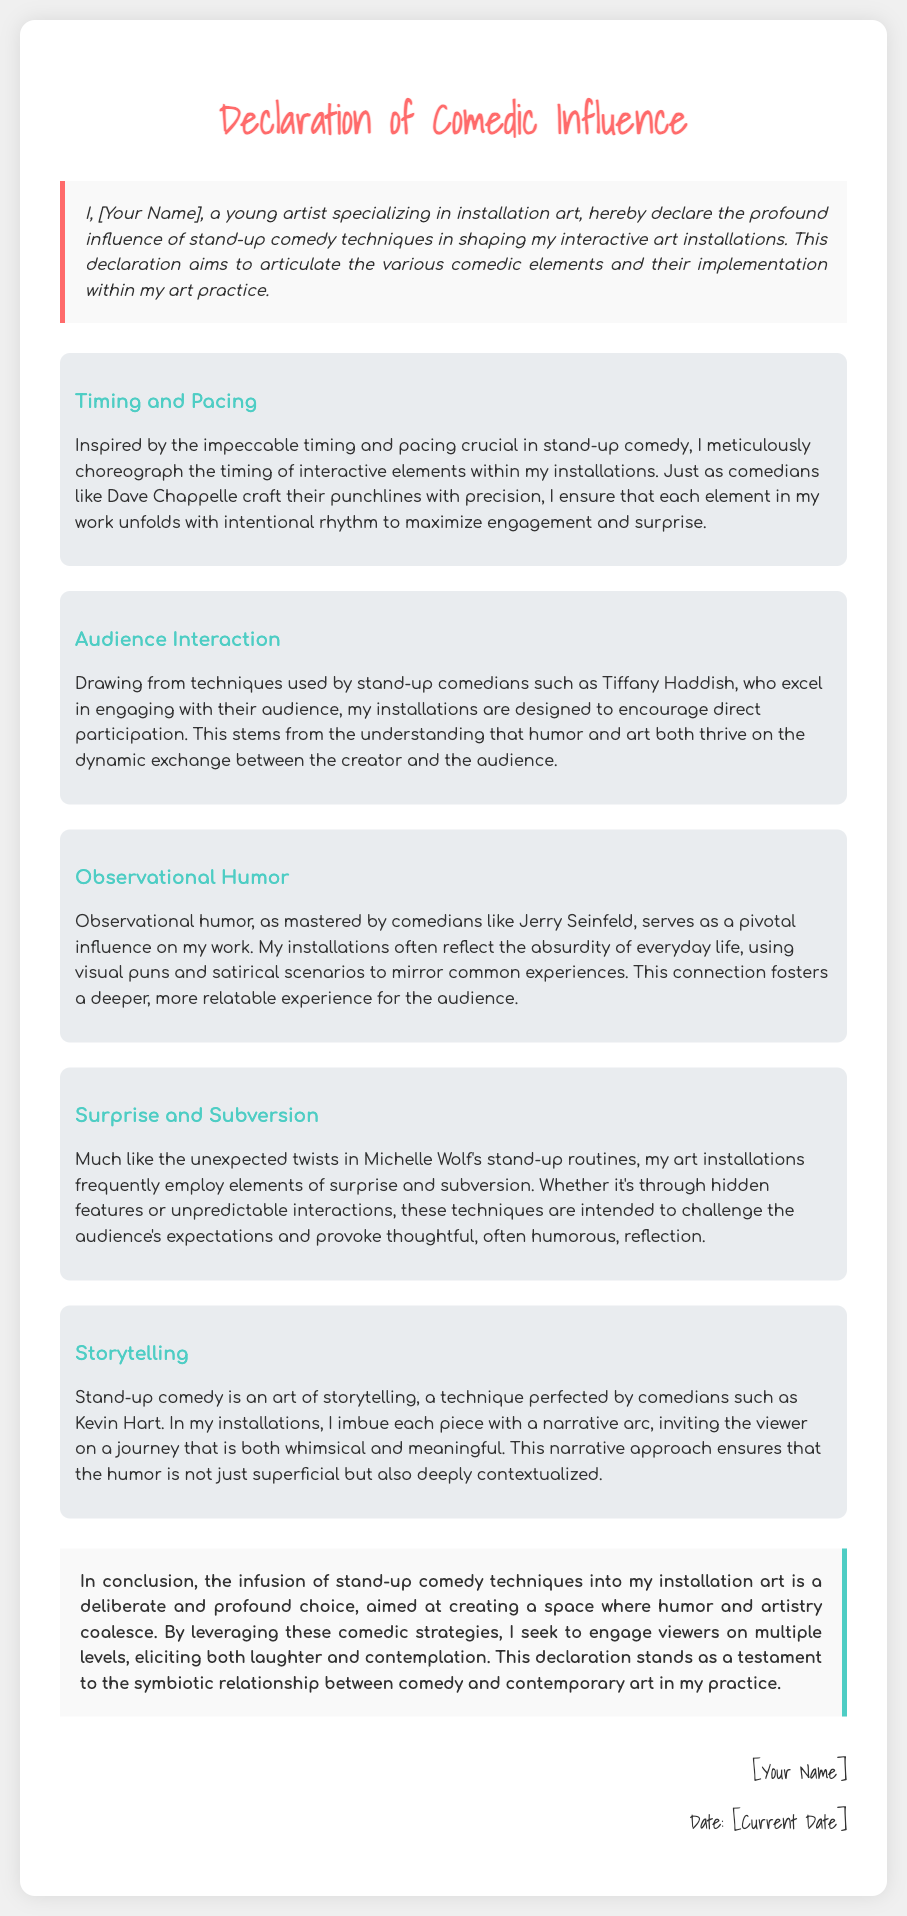what is the title of the document? The title of the document is stated in the header section, providing the main purpose of the text.
Answer: Declaration of Comedic Influence who is the author of the declaration? The author is mentioned in the introductory declaration where they specify their role as an artist.
Answer: [Your Name] which comedian's techniques are mentioned related to timing and pacing? The document refers to the work of a specific comedian known for their precise timing in humor.
Answer: Dave Chappelle what type of humor is emphasized in the influence point related to everyday life? The document highlights a specific comedic style based on common experiences.
Answer: Observational humor how many influence points are outlined in the document? The number of influence points is explicitly shown by the number of sections in the document.
Answer: Five which comedian is referenced in connection to storytelling? The document explicitly mentions a notable comedian known for their storytelling approach.
Answer: Kevin Hart what is the main conclusion of the document? The conclusion summarizes the primary goal of infusing comedy into art, reflecting the overall theme.
Answer: Humor and artistry coalesce on which date was this declaration signed? The date of signing is included in the closing section under the author's signature.
Answer: [Current Date] what color is used for the title text? The document specifies the color used for the main title, contributing to its visual appeal.
Answer: #ff6b6b 